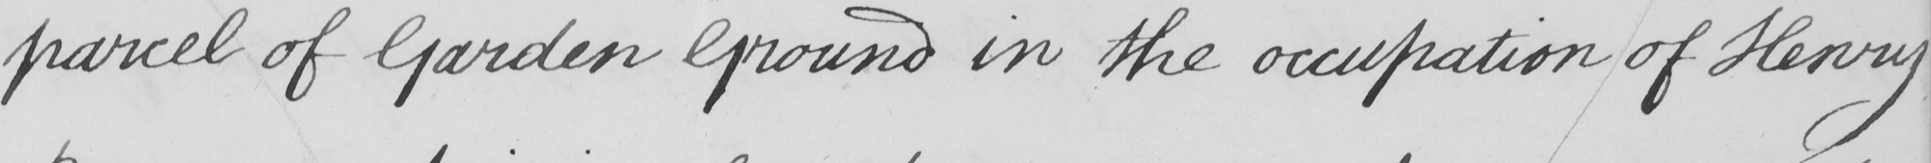Can you tell me what this handwritten text says? parcel of Garden Ground in the occupation of Henry 